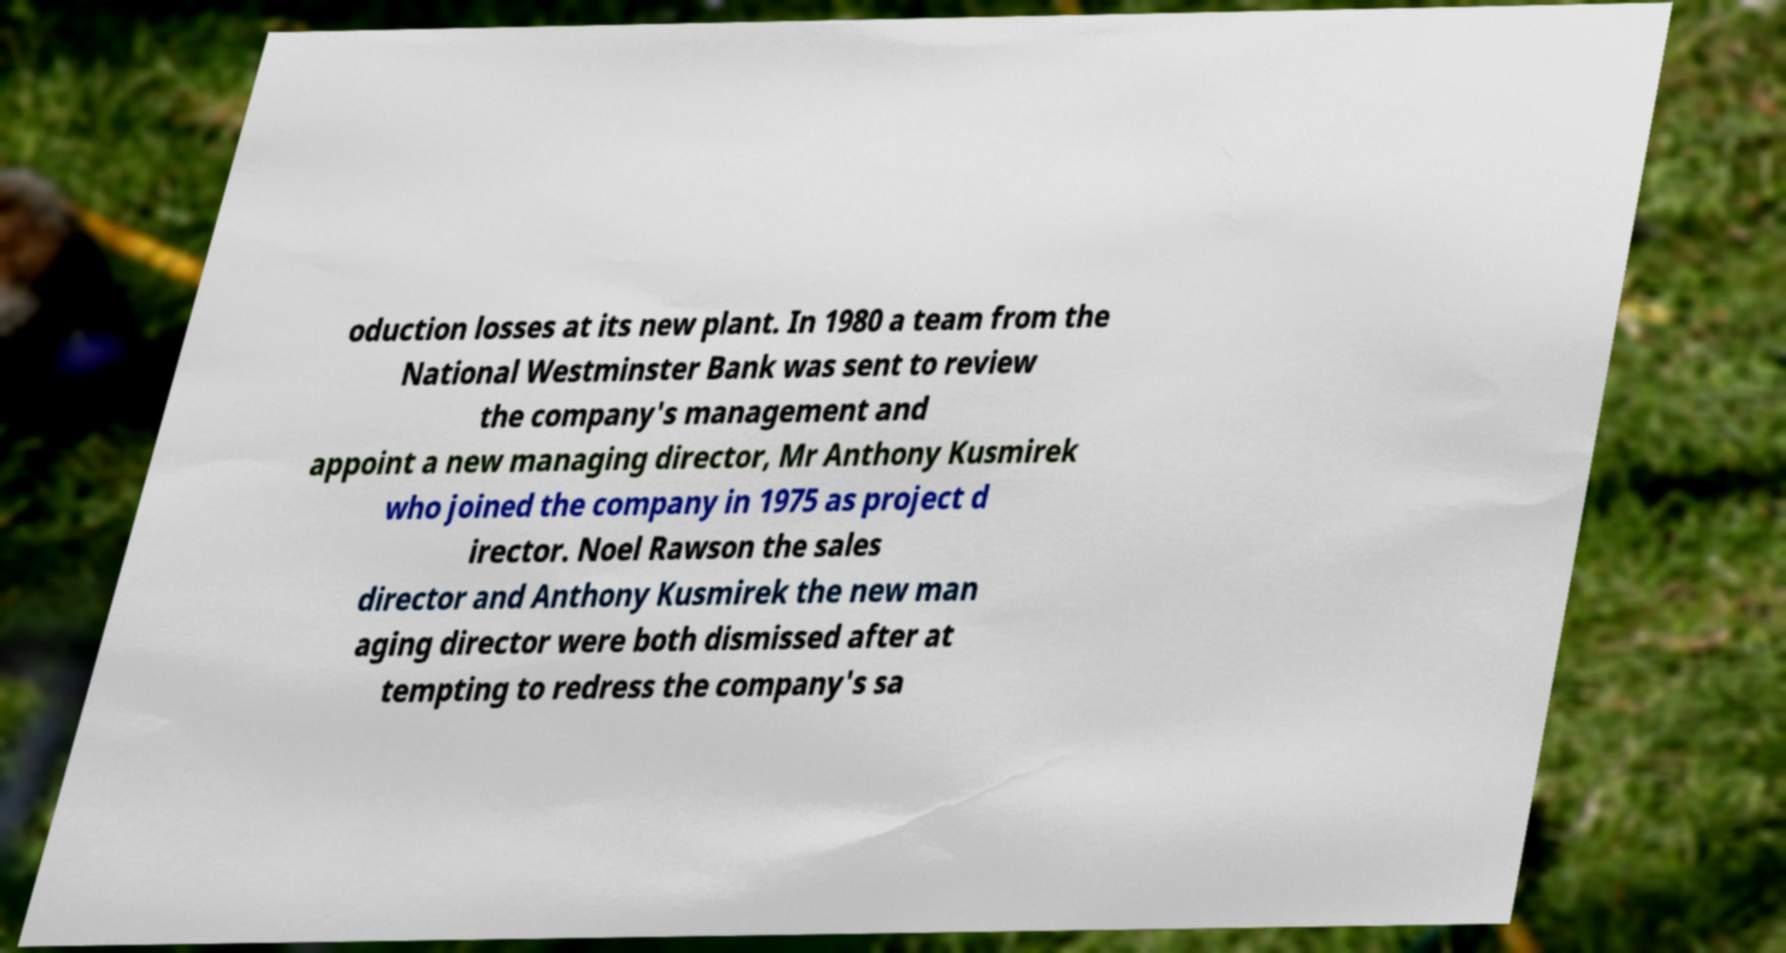Can you accurately transcribe the text from the provided image for me? oduction losses at its new plant. In 1980 a team from the National Westminster Bank was sent to review the company's management and appoint a new managing director, Mr Anthony Kusmirek who joined the company in 1975 as project d irector. Noel Rawson the sales director and Anthony Kusmirek the new man aging director were both dismissed after at tempting to redress the company's sa 